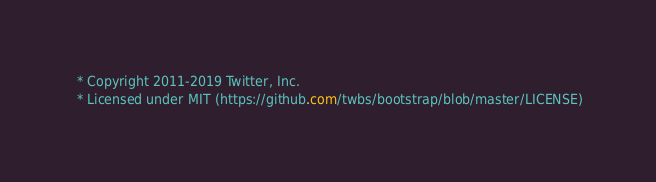<code> <loc_0><loc_0><loc_500><loc_500><_CSS_> * Copyright 2011-2019 Twitter, Inc.
 * Licensed under MIT (https://github.com/twbs/bootstrap/blob/master/LICENSE)</code> 